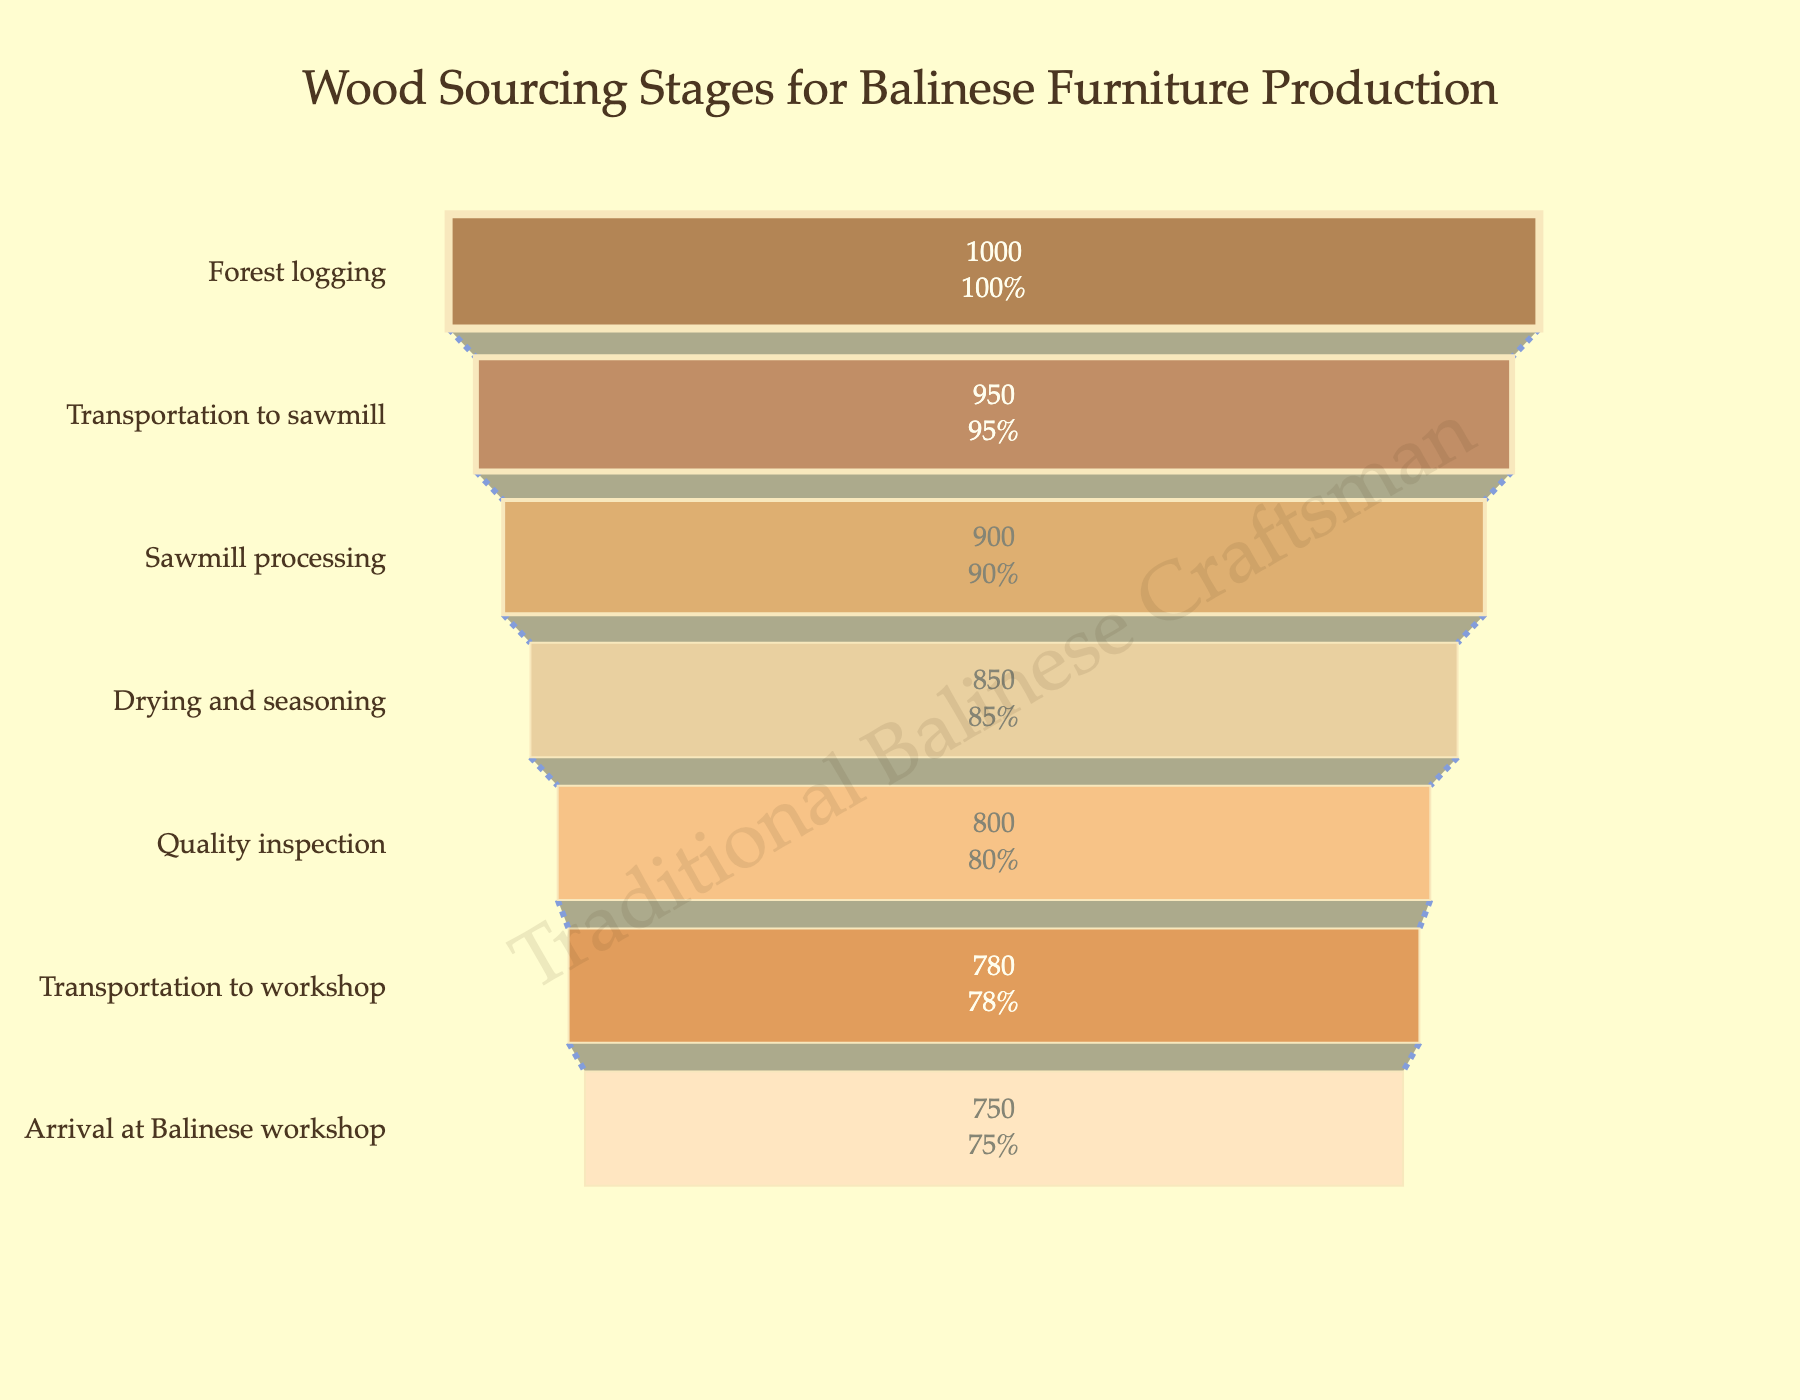What's the title of the funnel chart? The title of the funnel chart is prominently displayed at the top of the figure, it reads "Wood Sourcing Stages for Balinese Furniture Production."
Answer: Wood Sourcing Stages for Balinese Furniture Production How many stages are represented in the funnel chart? By counting the number of distinct stages or categories along the y-axis of the funnel chart, you can see that there are seven stages in total.
Answer: Seven What is the quantity of wood left after the sawmill processing stage? Referencing the specific stage labeled "Sawmill processing" in the funnel chart, you can find a quantity of 900 cubic meters.
Answer: 900 cubic meters What percentage of wood is lost between the "Forest logging" and "Arrival at Balinese workshop" stages? Start with the initial quantity at "Forest logging" (1000 cubic meters) and the final quantity at "Arrival at Balinese workshop" (750 cubic meters). The loss is 1000 - 750 = 250 cubic meters. The percentage loss is (250/1000) * 100 = 25%.
Answer: 25% Which stage has the smallest quantity of wood processed? By observing the lengths of the bars, which represent quantities, you can see that the stage "Arrival at Balinese workshop" has the smallest quantity, at 750 cubic meters.
Answer: Arrival at Balinese workshop How much wood is lost in the drying and seasoning stage? The quantity before the drying and seasoning stage is 900 cubic meters (Sawmill processing) and after is 850 cubic meters (Drying and seasoning). Thus, the loss is 900 - 850 = 50 cubic meters.
Answer: 50 cubic meters Compare the quantities between the "Transportation to workshop" and "Arrival at Balinese workshop" stages. Which is higher? Compare the bar lengths; "Transportation to workshop" has 780 cubic meters, while "Arrival at Balinese workshop" has 750 cubic meters. 780 cubic meters is higher than 750 cubic meters.
Answer: Transportation to workshop What is the total wood loss from "Forest logging" to "Quality inspection"? The quantity at "Forest logging" is 1000 cubic meters and "Quality inspection" is 800 cubic meters. The loss is 1000 - 800 = 200 cubic meters.
Answer: 200 cubic meters Which stage follows "Drying and seasoning" and what is the quantity of wood in that stage? The stage that follows "Drying and seasoning" is "Quality inspection." The quantity of wood in this stage is 800 cubic meters.
Answer: Quality inspection, 800 cubic meters How is the color of the "Transportation to sawmill" stage visually distinct? The "Transportation to sawmill" stage has a distinct color which appears darker, specifically a saddle brown shade, among the other shades of brown used in the funnel chart.
Answer: Saddle brown shade (dark brown) 